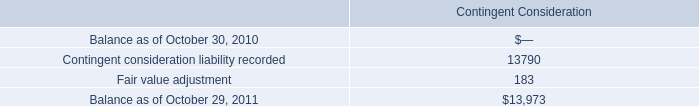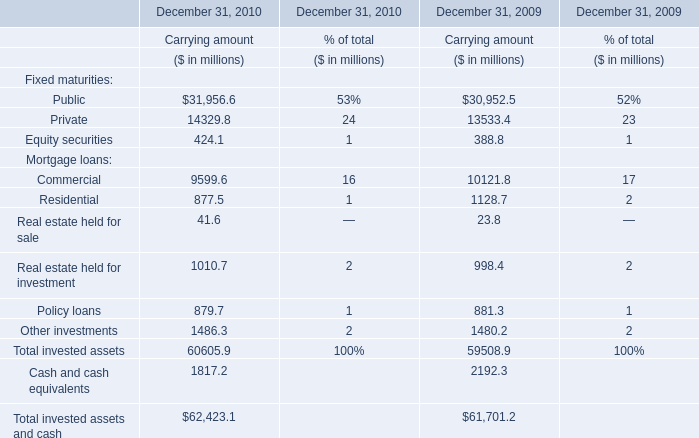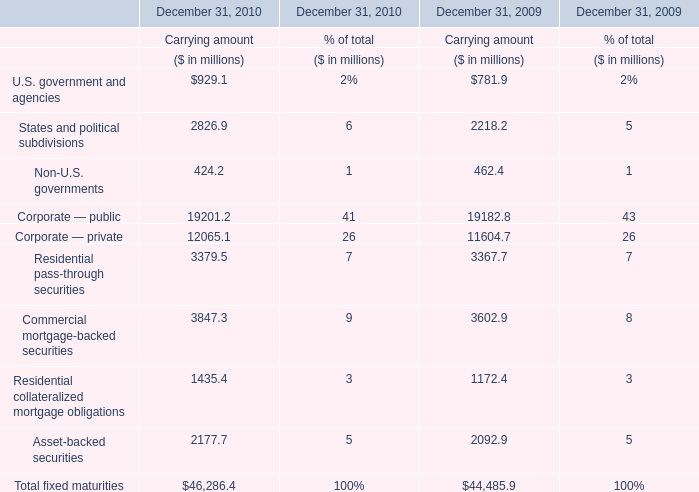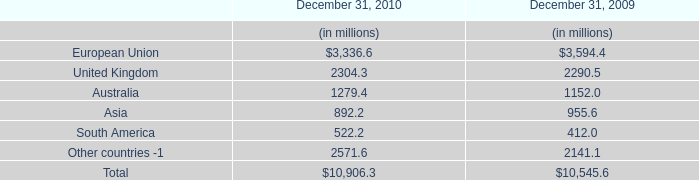What is the ratio of Corporate — public to the total in 2009? (in %) 
Computations: (19182.8 / 44485.9)
Answer: 0.43121. 